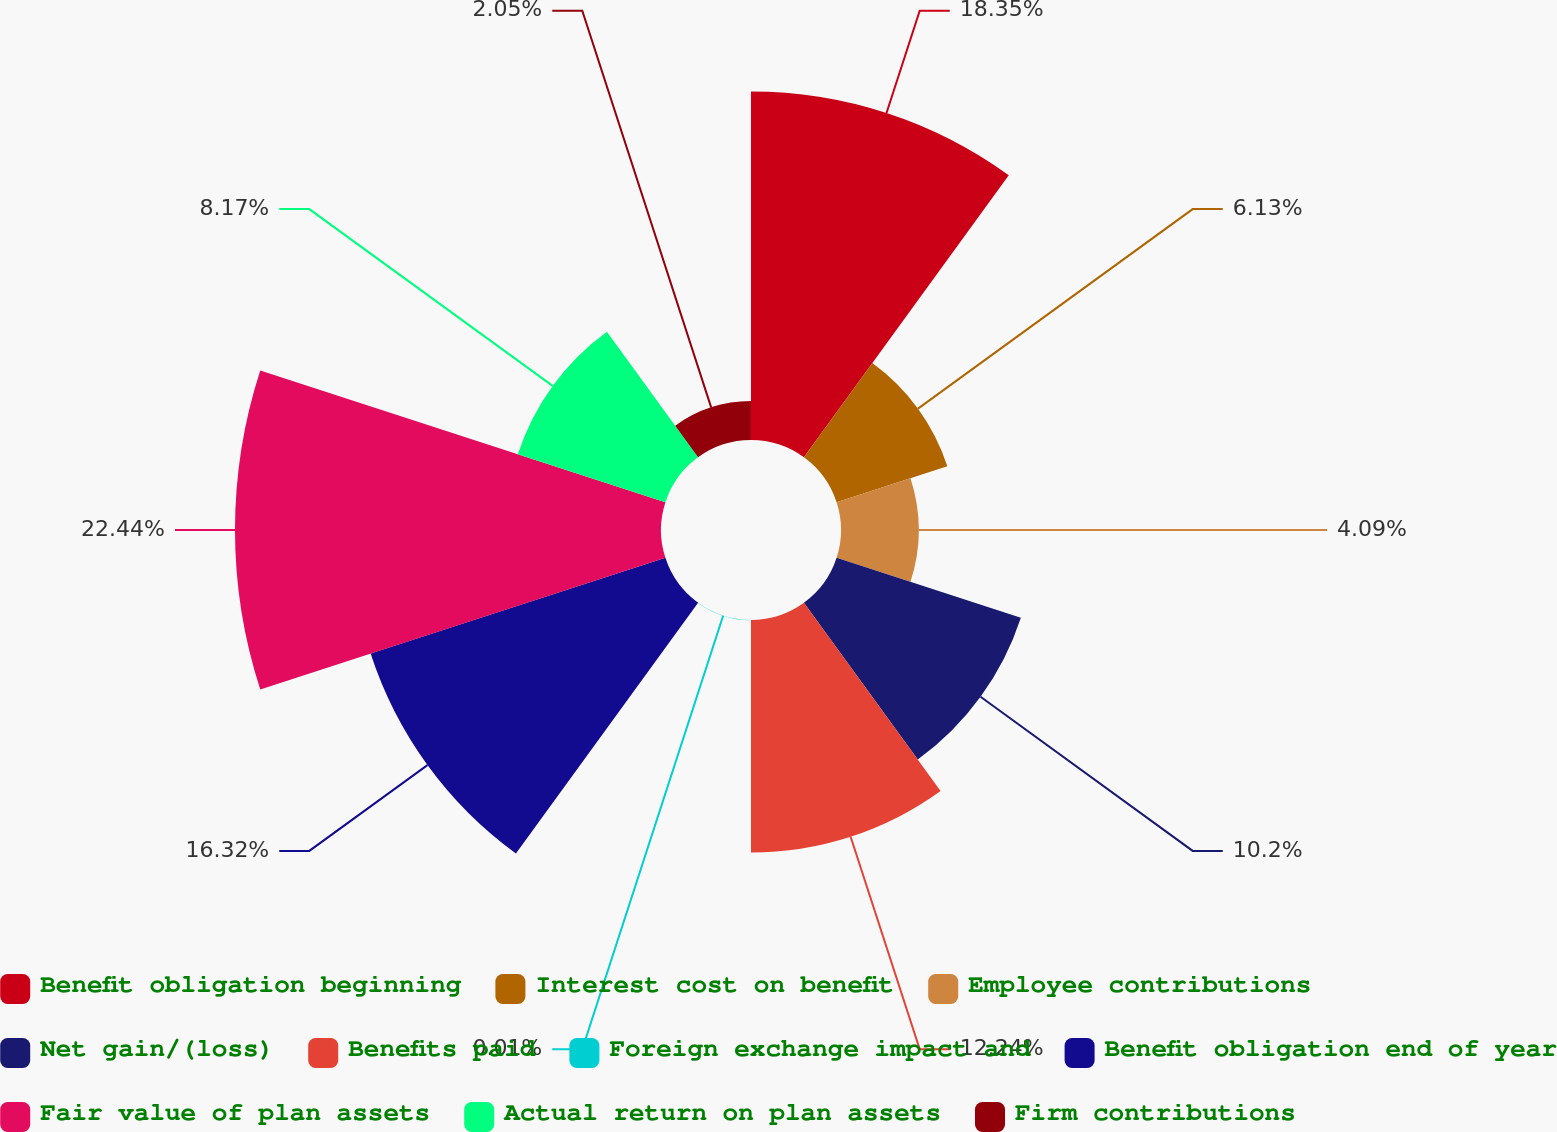Convert chart to OTSL. <chart><loc_0><loc_0><loc_500><loc_500><pie_chart><fcel>Benefit obligation beginning<fcel>Interest cost on benefit<fcel>Employee contributions<fcel>Net gain/(loss)<fcel>Benefits paid<fcel>Foreign exchange impact and<fcel>Benefit obligation end of year<fcel>Fair value of plan assets<fcel>Actual return on plan assets<fcel>Firm contributions<nl><fcel>18.35%<fcel>6.13%<fcel>4.09%<fcel>10.2%<fcel>12.24%<fcel>0.01%<fcel>16.32%<fcel>22.43%<fcel>8.17%<fcel>2.05%<nl></chart> 